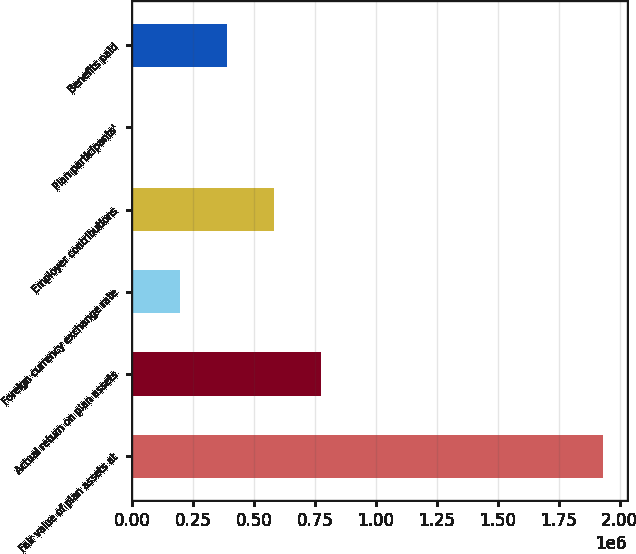Convert chart. <chart><loc_0><loc_0><loc_500><loc_500><bar_chart><fcel>Fair value of plan assets at<fcel>Actual return on plan assets<fcel>Foreign currency exchange rate<fcel>Employer contributions<fcel>Plan participants'<fcel>Benefits paid<nl><fcel>1.93306e+06<fcel>775351<fcel>196495<fcel>582399<fcel>3543<fcel>389447<nl></chart> 